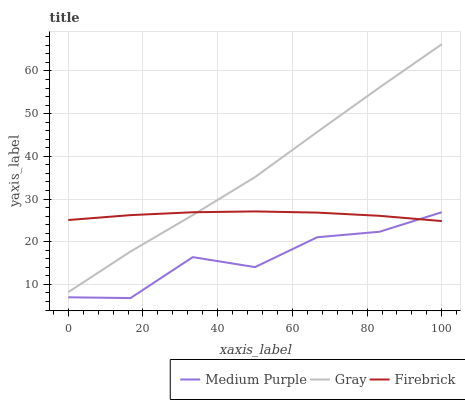Does Medium Purple have the minimum area under the curve?
Answer yes or no. Yes. Does Gray have the maximum area under the curve?
Answer yes or no. Yes. Does Firebrick have the minimum area under the curve?
Answer yes or no. No. Does Firebrick have the maximum area under the curve?
Answer yes or no. No. Is Firebrick the smoothest?
Answer yes or no. Yes. Is Medium Purple the roughest?
Answer yes or no. Yes. Is Gray the smoothest?
Answer yes or no. No. Is Gray the roughest?
Answer yes or no. No. Does Medium Purple have the lowest value?
Answer yes or no. Yes. Does Gray have the lowest value?
Answer yes or no. No. Does Gray have the highest value?
Answer yes or no. Yes. Does Firebrick have the highest value?
Answer yes or no. No. Is Medium Purple less than Gray?
Answer yes or no. Yes. Is Gray greater than Medium Purple?
Answer yes or no. Yes. Does Firebrick intersect Gray?
Answer yes or no. Yes. Is Firebrick less than Gray?
Answer yes or no. No. Is Firebrick greater than Gray?
Answer yes or no. No. Does Medium Purple intersect Gray?
Answer yes or no. No. 